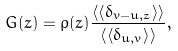Convert formula to latex. <formula><loc_0><loc_0><loc_500><loc_500>G ( z ) = \rho ( z ) \frac { \left \langle \left \langle \delta _ { v - u , z } \right \rangle \right \rangle } { \left \langle \left \langle \delta _ { u , v } \right \rangle \right \rangle } ,</formula> 